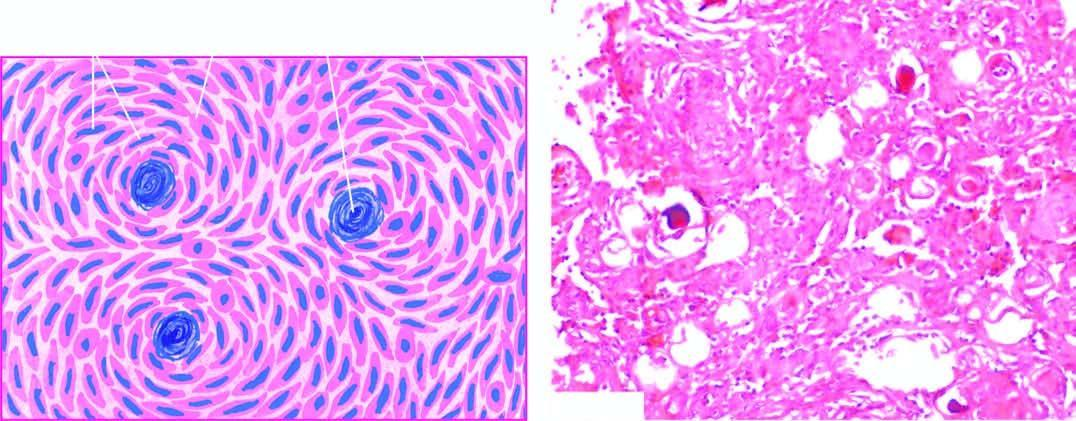do the cells have features of both syncytial and fibroblastic type and form whorled appearance?
Answer the question using a single word or phrase. Yes 